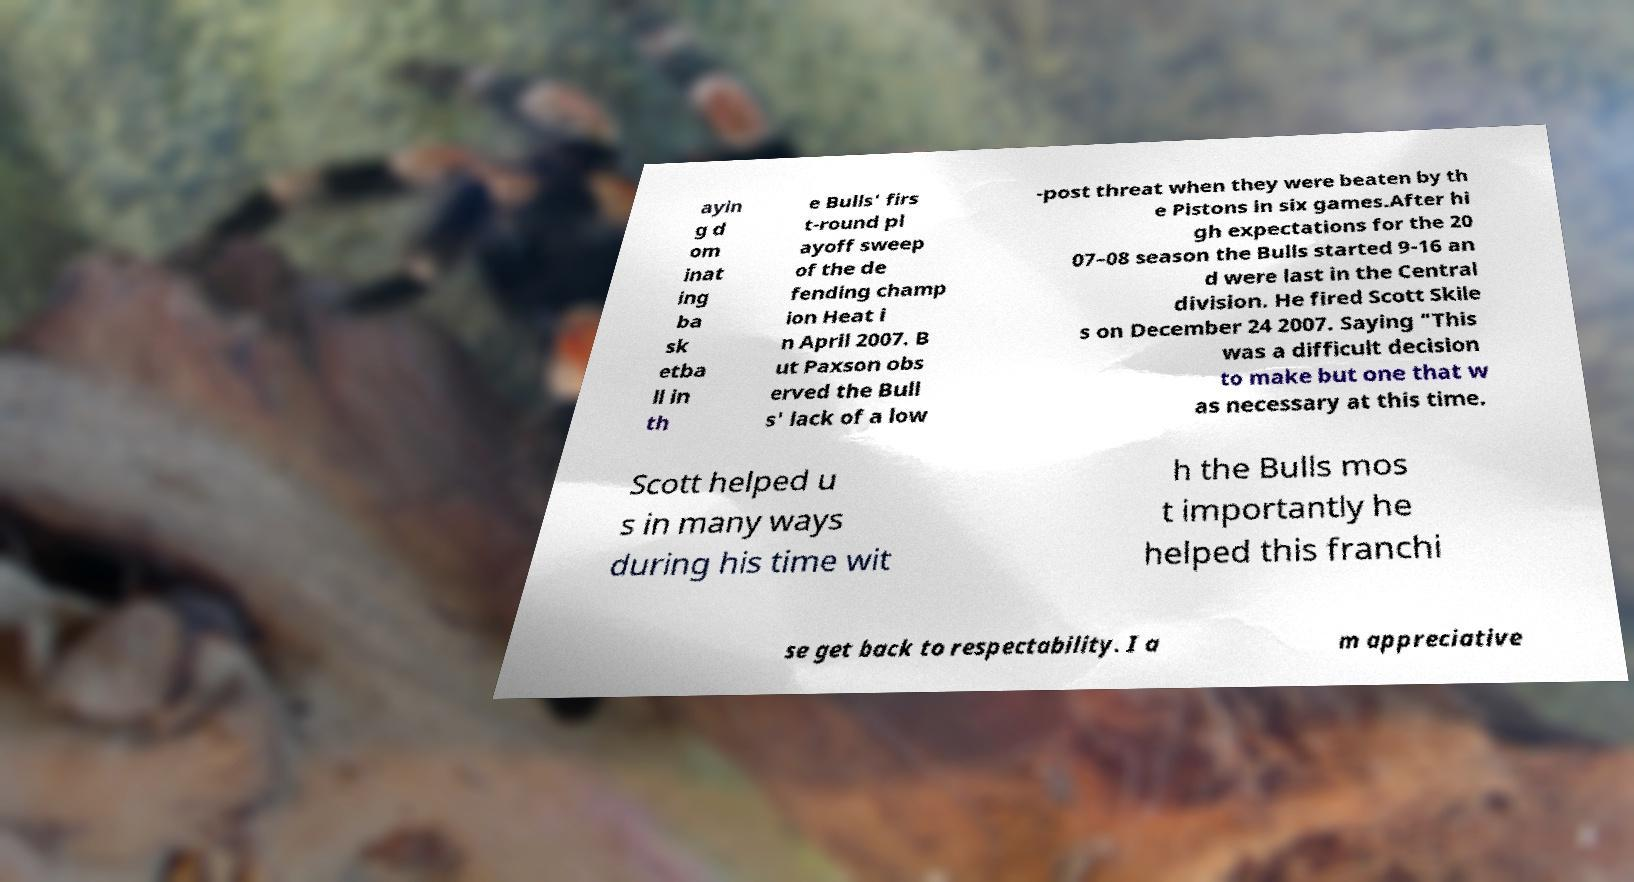There's text embedded in this image that I need extracted. Can you transcribe it verbatim? ayin g d om inat ing ba sk etba ll in th e Bulls' firs t-round pl ayoff sweep of the de fending champ ion Heat i n April 2007. B ut Paxson obs erved the Bull s' lack of a low -post threat when they were beaten by th e Pistons in six games.After hi gh expectations for the 20 07–08 season the Bulls started 9-16 an d were last in the Central division. He fired Scott Skile s on December 24 2007. Saying "This was a difficult decision to make but one that w as necessary at this time. Scott helped u s in many ways during his time wit h the Bulls mos t importantly he helped this franchi se get back to respectability. I a m appreciative 